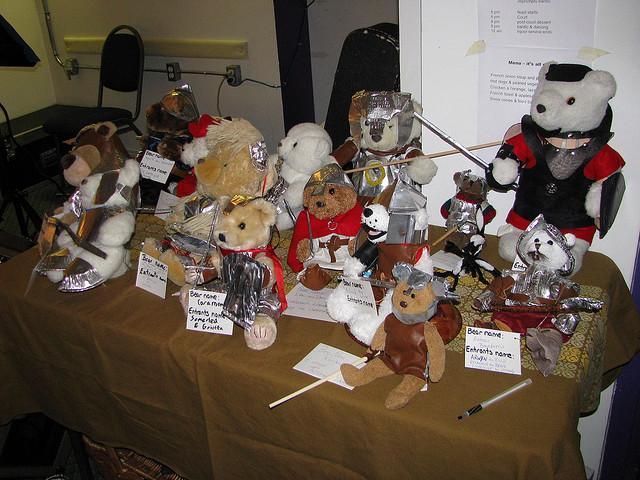How many bears are on the table?
Keep it brief. 14. What color is the chair?
Quick response, please. Black. Are this for sale?
Short answer required. Yes. Are some bears dressed as knights?
Quick response, please. Yes. What color is the tablecloth?
Give a very brief answer. Brown. 